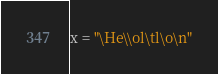<code> <loc_0><loc_0><loc_500><loc_500><_Python_>x = "\He\\ol\tl\o\n"</code> 